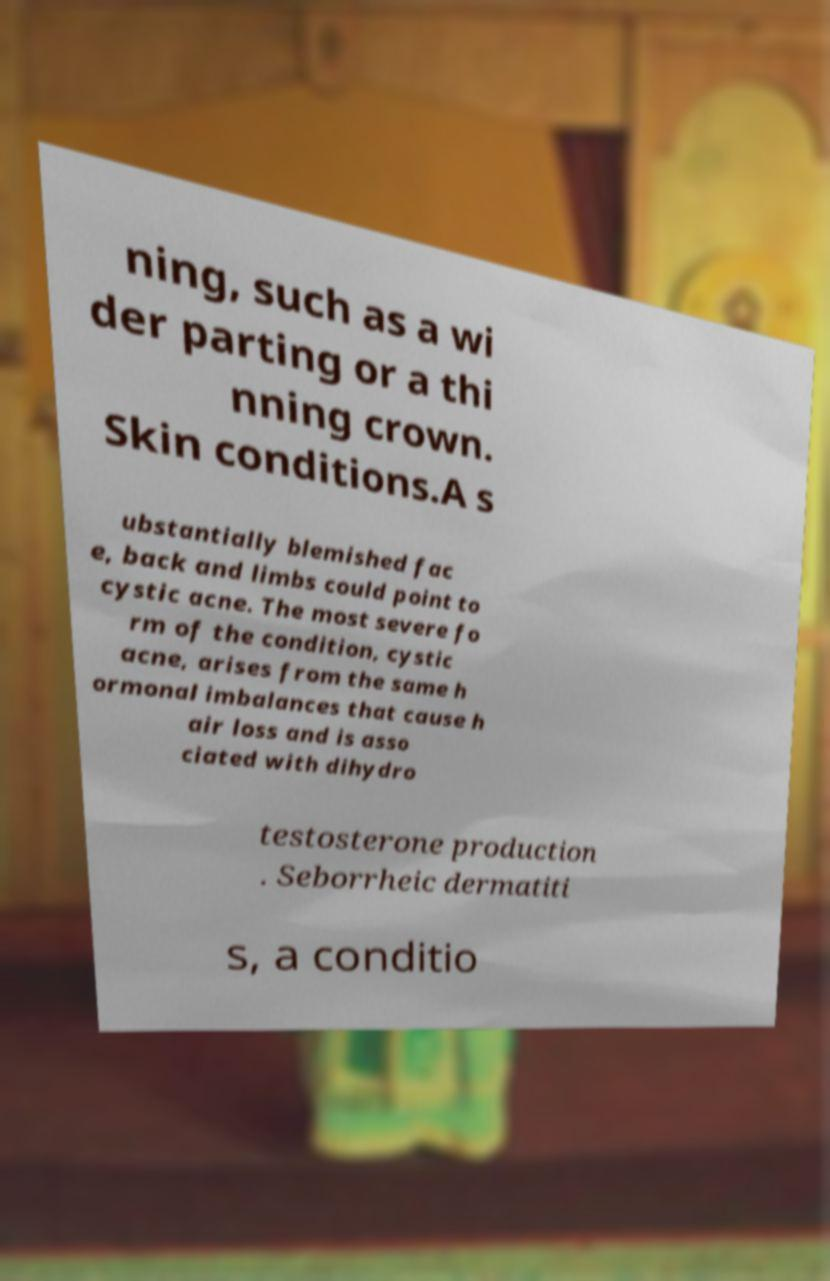Can you accurately transcribe the text from the provided image for me? ning, such as a wi der parting or a thi nning crown. Skin conditions.A s ubstantially blemished fac e, back and limbs could point to cystic acne. The most severe fo rm of the condition, cystic acne, arises from the same h ormonal imbalances that cause h air loss and is asso ciated with dihydro testosterone production . Seborrheic dermatiti s, a conditio 